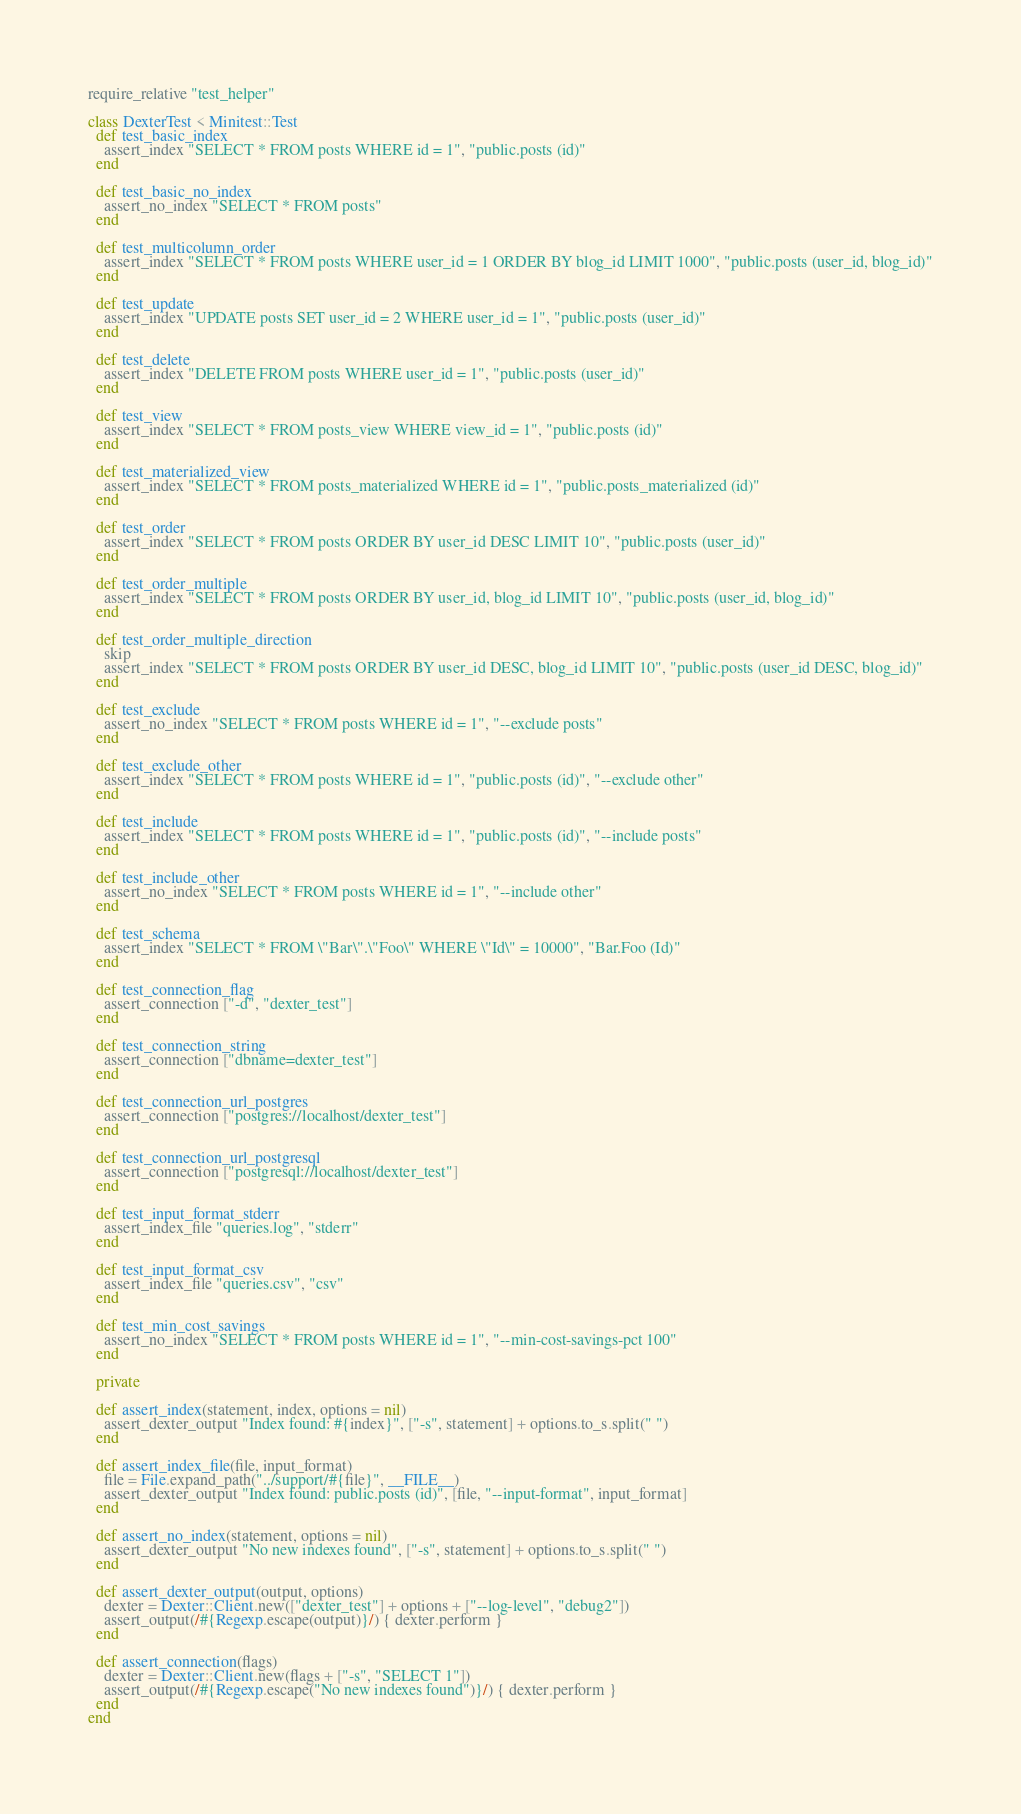<code> <loc_0><loc_0><loc_500><loc_500><_Ruby_>require_relative "test_helper"

class DexterTest < Minitest::Test
  def test_basic_index
    assert_index "SELECT * FROM posts WHERE id = 1", "public.posts (id)"
  end

  def test_basic_no_index
    assert_no_index "SELECT * FROM posts"
  end

  def test_multicolumn_order
    assert_index "SELECT * FROM posts WHERE user_id = 1 ORDER BY blog_id LIMIT 1000", "public.posts (user_id, blog_id)"
  end

  def test_update
    assert_index "UPDATE posts SET user_id = 2 WHERE user_id = 1", "public.posts (user_id)"
  end

  def test_delete
    assert_index "DELETE FROM posts WHERE user_id = 1", "public.posts (user_id)"
  end

  def test_view
    assert_index "SELECT * FROM posts_view WHERE view_id = 1", "public.posts (id)"
  end

  def test_materialized_view
    assert_index "SELECT * FROM posts_materialized WHERE id = 1", "public.posts_materialized (id)"
  end

  def test_order
    assert_index "SELECT * FROM posts ORDER BY user_id DESC LIMIT 10", "public.posts (user_id)"
  end

  def test_order_multiple
    assert_index "SELECT * FROM posts ORDER BY user_id, blog_id LIMIT 10", "public.posts (user_id, blog_id)"
  end

  def test_order_multiple_direction
    skip
    assert_index "SELECT * FROM posts ORDER BY user_id DESC, blog_id LIMIT 10", "public.posts (user_id DESC, blog_id)"
  end

  def test_exclude
    assert_no_index "SELECT * FROM posts WHERE id = 1", "--exclude posts"
  end

  def test_exclude_other
    assert_index "SELECT * FROM posts WHERE id = 1", "public.posts (id)", "--exclude other"
  end

  def test_include
    assert_index "SELECT * FROM posts WHERE id = 1", "public.posts (id)", "--include posts"
  end

  def test_include_other
    assert_no_index "SELECT * FROM posts WHERE id = 1", "--include other"
  end

  def test_schema
    assert_index "SELECT * FROM \"Bar\".\"Foo\" WHERE \"Id\" = 10000", "Bar.Foo (Id)"
  end

  def test_connection_flag
    assert_connection ["-d", "dexter_test"]
  end

  def test_connection_string
    assert_connection ["dbname=dexter_test"]
  end

  def test_connection_url_postgres
    assert_connection ["postgres://localhost/dexter_test"]
  end

  def test_connection_url_postgresql
    assert_connection ["postgresql://localhost/dexter_test"]
  end

  def test_input_format_stderr
    assert_index_file "queries.log", "stderr"
  end

  def test_input_format_csv
    assert_index_file "queries.csv", "csv"
  end

  def test_min_cost_savings
    assert_no_index "SELECT * FROM posts WHERE id = 1", "--min-cost-savings-pct 100"
  end

  private

  def assert_index(statement, index, options = nil)
    assert_dexter_output "Index found: #{index}", ["-s", statement] + options.to_s.split(" ")
  end

  def assert_index_file(file, input_format)
    file = File.expand_path("../support/#{file}", __FILE__)
    assert_dexter_output "Index found: public.posts (id)", [file, "--input-format", input_format]
  end

  def assert_no_index(statement, options = nil)
    assert_dexter_output "No new indexes found", ["-s", statement] + options.to_s.split(" ")
  end

  def assert_dexter_output(output, options)
    dexter = Dexter::Client.new(["dexter_test"] + options + ["--log-level", "debug2"])
    assert_output(/#{Regexp.escape(output)}/) { dexter.perform }
  end

  def assert_connection(flags)
    dexter = Dexter::Client.new(flags + ["-s", "SELECT 1"])
    assert_output(/#{Regexp.escape("No new indexes found")}/) { dexter.perform }
  end
end
</code> 